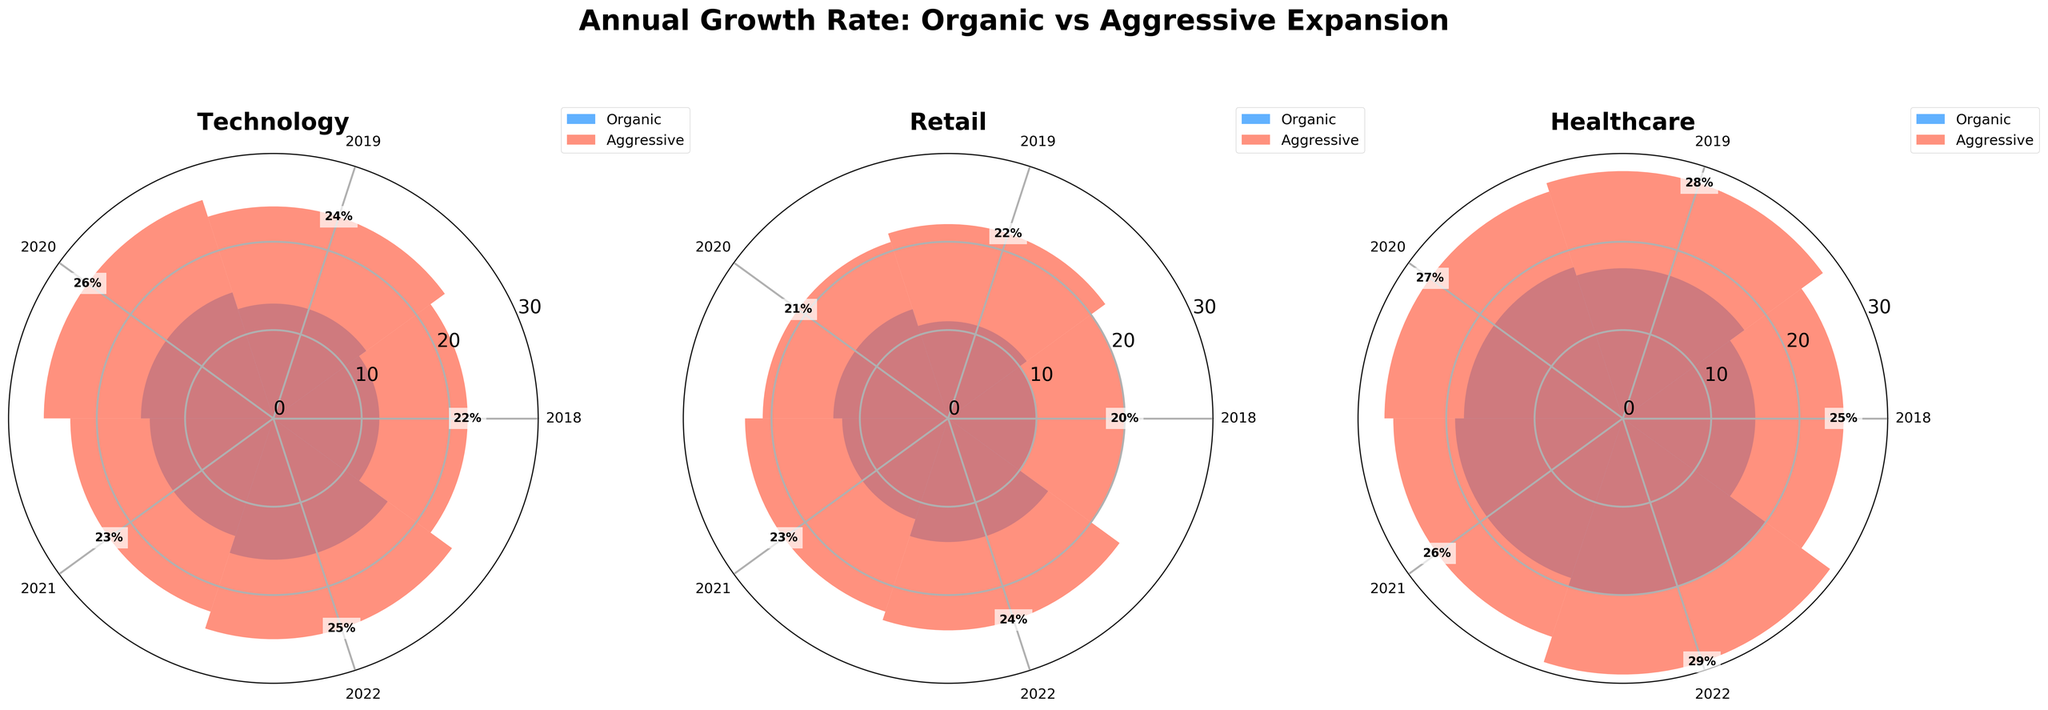What is the title of the plot? The title of the plot is usually found at the top center of the figure. The rendered figure has the title "Annual Growth Rate: Organic vs Aggressive Expansion".
Answer: Annual Growth Rate: Organic vs Aggressive Expansion Which category has the highest growth rate in 2022 under the aggressive strategy? To find the highest growth rate in 2022 for the aggressive strategy, look at the bars representing 2022 in the aggressive strategy for each subplot. For Technology (FastTrack), it's 25%, for Retail (QuickRetail) it's 24%, and for Healthcare (MediExpand) it's 29%.
Answer: Healthcare What is the average annual growth rate of Organic strategy for TechCo between 2018 and 2022? To get the average, sum the growth rates of Organic strategy for TechCo from 2018 to 2022 and divide by the number of years. The growth rates are 12%, 13%, 15%, 14%, and 16%. Thus, (12 + 13 + 15 + 14 + 16) / 5 = 70 / 5 = 14%.
Answer: 14% How does the annual growth rate of HealthLife in 2018 compare with its growth rate in 2022? Look at the polar plot for Healthcare to compare HealthLife's Organic strategy growth rates in 2018 and 2022. In 2018, the rate is 15%, and in 2022 it is 20%.
Answer: Increased by 5% Which company had the smallest variation in annual growth rates over the years under the organic strategy? To determine the smallest variation, calculate the range (difference between highest and lowest growth rates) for each company under the Organic strategy. For TechCo (16% - 12% = 4%), for ShopEase (14% - 10% = 4%), and for HealthLife (20% - 15% = 5%).
Answer: TechCo or ShopEase Which year had the highest combined growth rate for the aggressive strategy across all categories? Sum the growth rates for the aggressive strategy in each year across all categories. For 2018 (22% + 20% + 25% = 67%), for 2019 (24% + 22% + 28% = 74%), for 2020 (26% + 21% + 27% = 74%), for 2021 (23% + 23% + 26% = 72%), and for 2022 (25% + 24% + 29% = 78%).
Answer: 2022 How do the annual growth rates in Retail under the Organic strategy in 2019 and 2021 compare? In the Retail subplot, compare the bars for 2019 and 2021 under the Organic strategy by referring to ShopEase's data. The growth rate in 2019 is 11% and in 2021 it is 12%.
Answer: Increased by 1% What is the trend of the annual growth rate in Technology under the Aggressive strategy from 2018 to 2022? Observe the progression of the bars in the Technology subplot for the years 2018 to 2022 under the Aggressive strategy. The rates are 22%, 24%, 26%, 23%, and 25%.
Answer: Generally increasing with a dip in 2021 